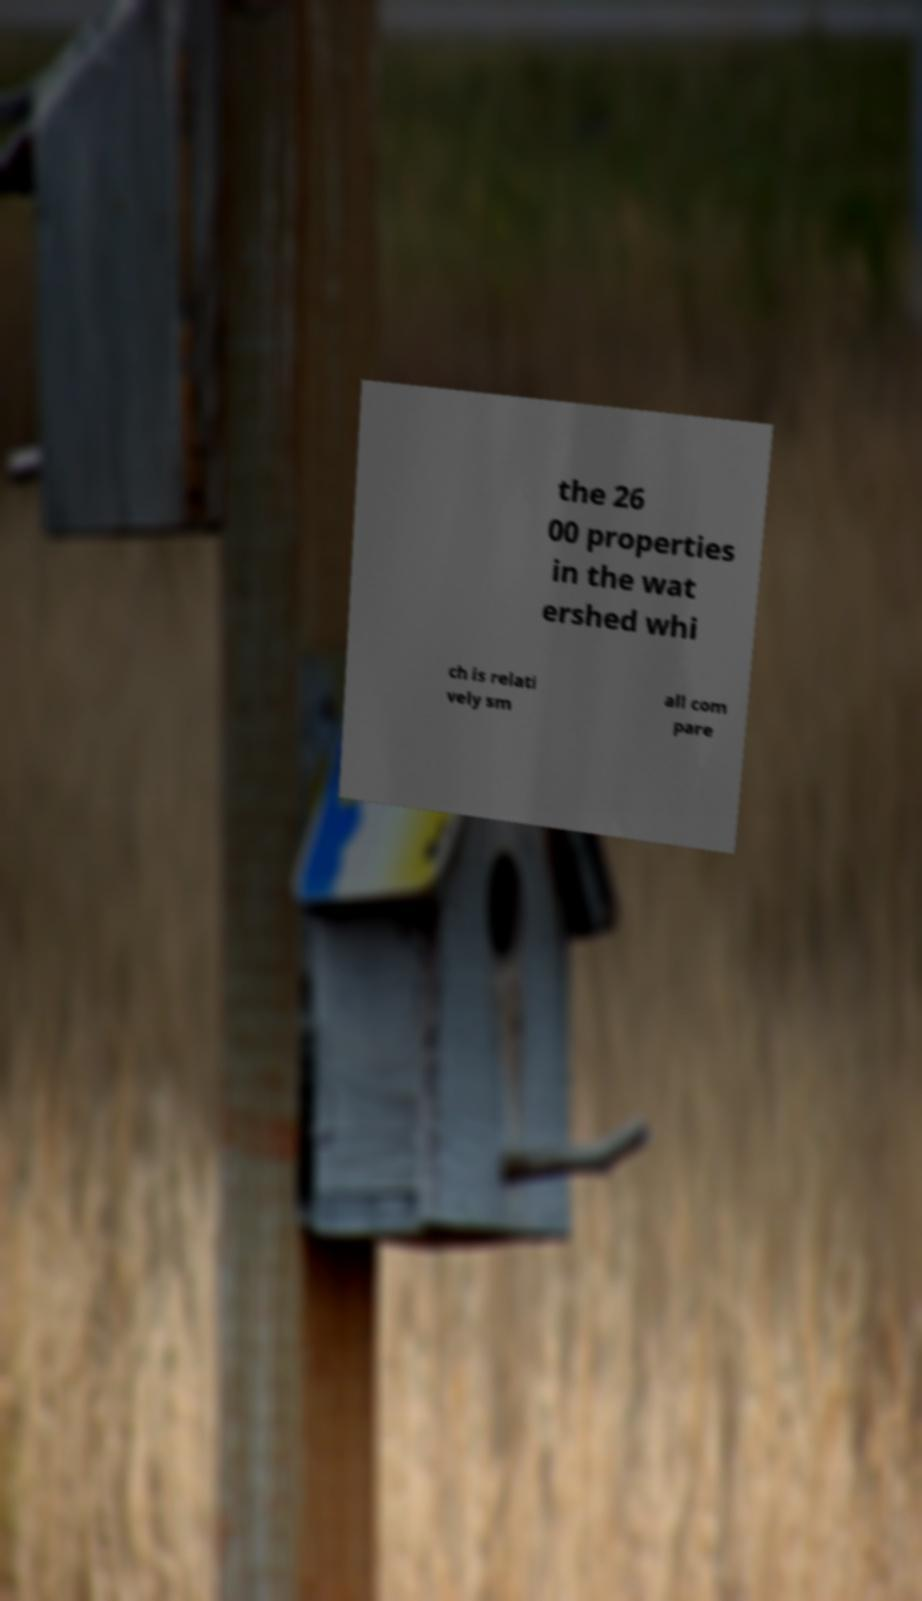Please identify and transcribe the text found in this image. the 26 00 properties in the wat ershed whi ch is relati vely sm all com pare 